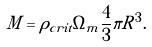<formula> <loc_0><loc_0><loc_500><loc_500>M = \rho _ { c r i t } \Omega _ { m } \frac { 4 } { 3 } \pi R ^ { 3 } .</formula> 